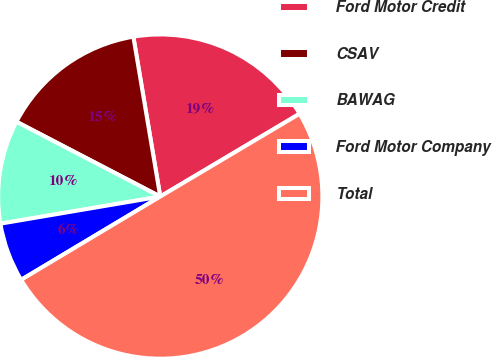Convert chart to OTSL. <chart><loc_0><loc_0><loc_500><loc_500><pie_chart><fcel>Ford Motor Credit<fcel>CSAV<fcel>BAWAG<fcel>Ford Motor Company<fcel>Total<nl><fcel>19.12%<fcel>14.71%<fcel>10.31%<fcel>5.91%<fcel>49.95%<nl></chart> 